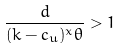Convert formula to latex. <formula><loc_0><loc_0><loc_500><loc_500>\frac { d } { ( k - c _ { u } ) ^ { x } \theta } > 1</formula> 